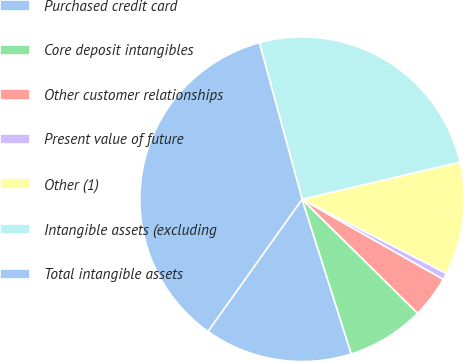Convert chart. <chart><loc_0><loc_0><loc_500><loc_500><pie_chart><fcel>Purchased credit card<fcel>Core deposit intangibles<fcel>Other customer relationships<fcel>Present value of future<fcel>Other (1)<fcel>Intangible assets (excluding<fcel>Total intangible assets<nl><fcel>14.75%<fcel>7.71%<fcel>4.18%<fcel>0.66%<fcel>11.23%<fcel>25.56%<fcel>35.9%<nl></chart> 